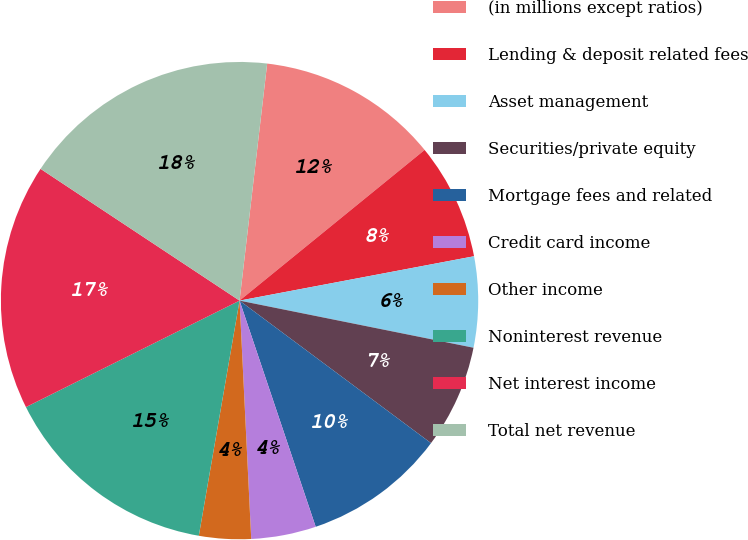Convert chart. <chart><loc_0><loc_0><loc_500><loc_500><pie_chart><fcel>(in millions except ratios)<fcel>Lending & deposit related fees<fcel>Asset management<fcel>Securities/private equity<fcel>Mortgage fees and related<fcel>Credit card income<fcel>Other income<fcel>Noninterest revenue<fcel>Net interest income<fcel>Total net revenue<nl><fcel>12.28%<fcel>7.9%<fcel>6.14%<fcel>7.02%<fcel>9.65%<fcel>4.39%<fcel>3.51%<fcel>14.91%<fcel>16.67%<fcel>17.54%<nl></chart> 